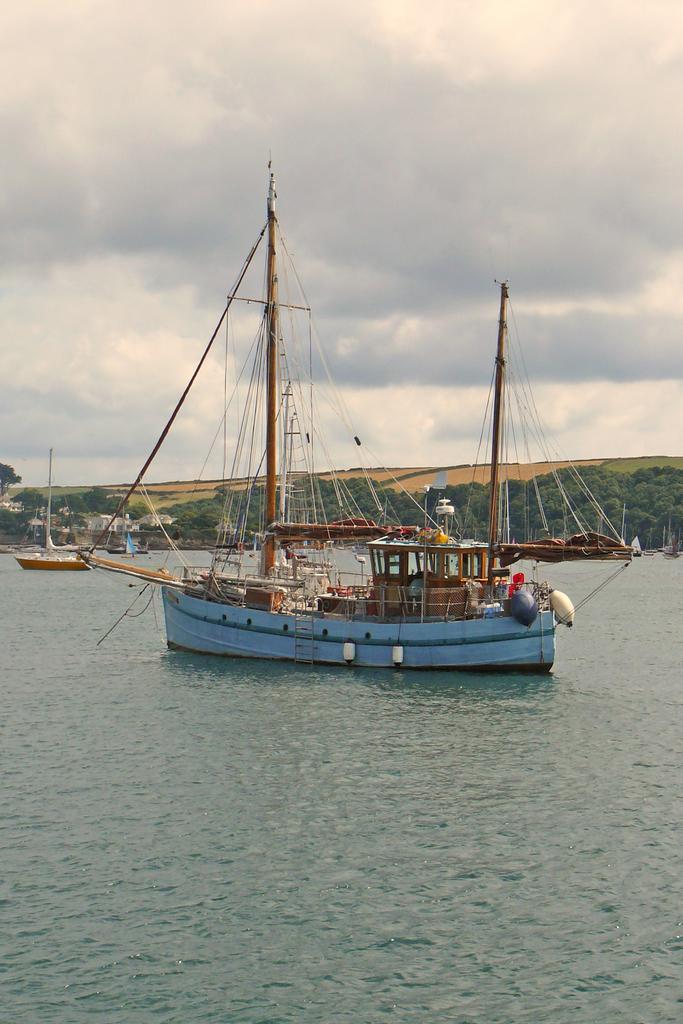Can you describe this image briefly? In this image there is the water. There are boats on the water. In the background there are mountains and trees. At the top there is the sky. 